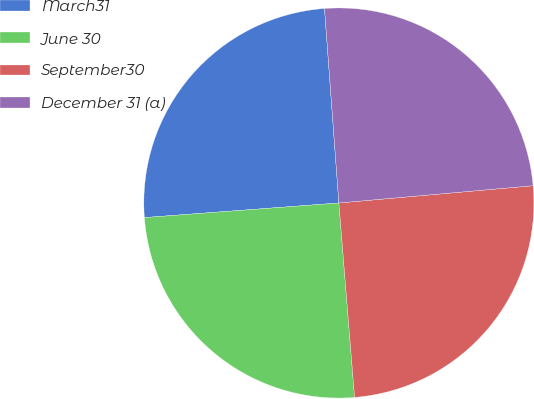<chart> <loc_0><loc_0><loc_500><loc_500><pie_chart><fcel>March31<fcel>June 30<fcel>September30<fcel>December 31 (a)<nl><fcel>25.02%<fcel>25.09%<fcel>25.13%<fcel>24.76%<nl></chart> 